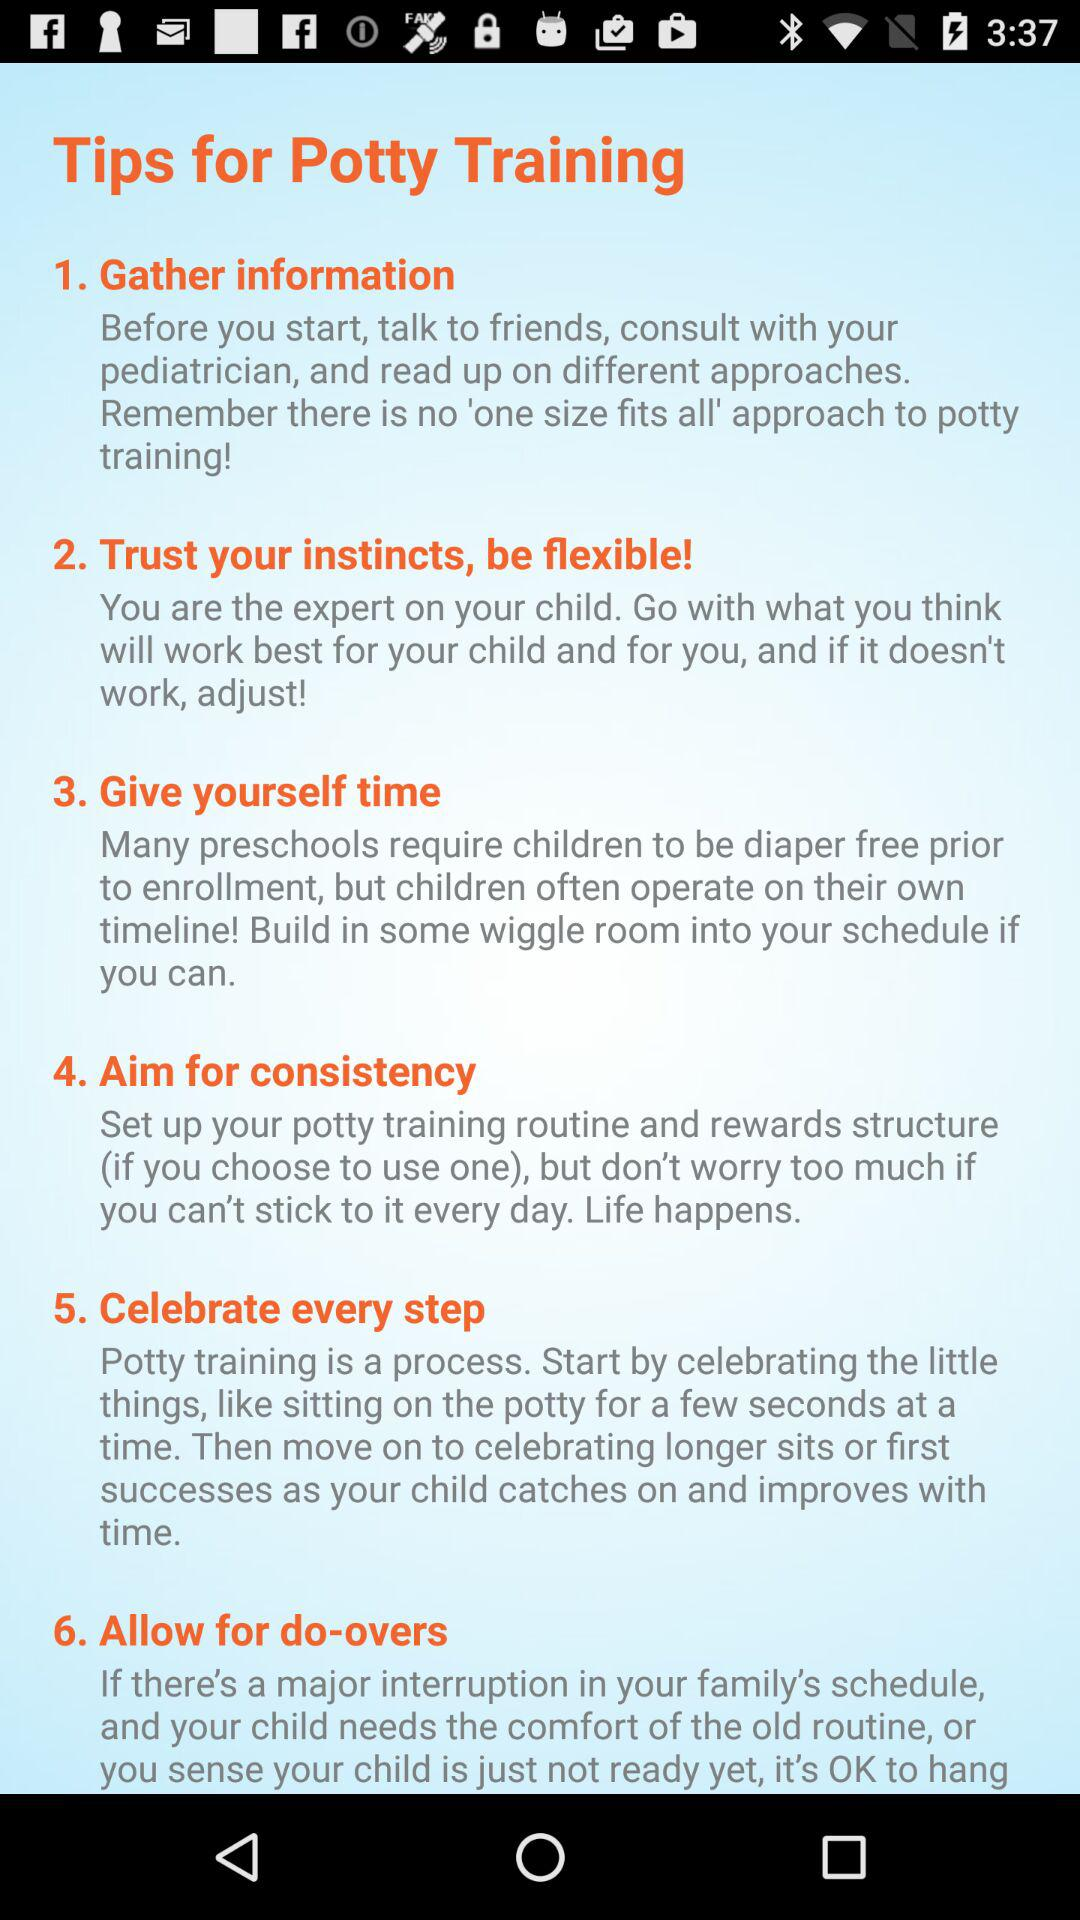How many tips are there for potty training?
Answer the question using a single word or phrase. 6 